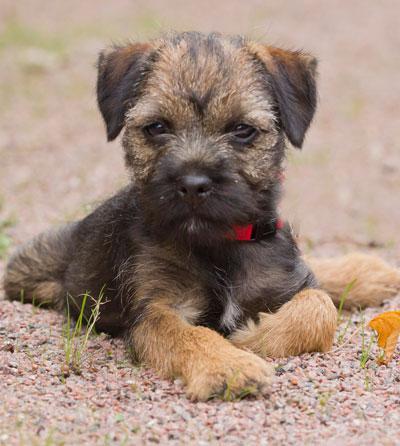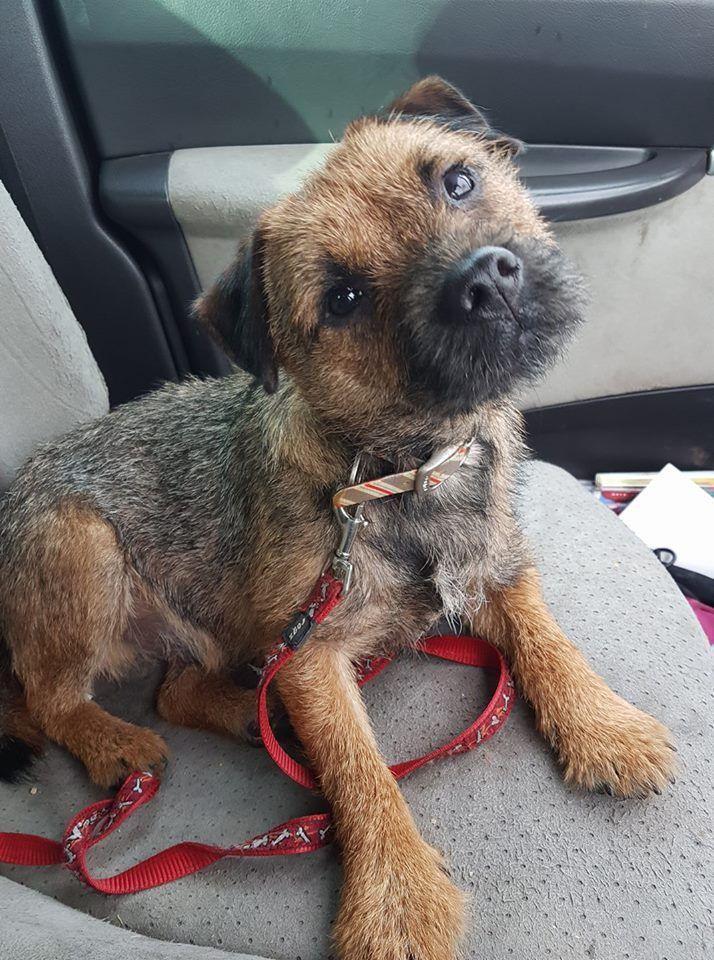The first image is the image on the left, the second image is the image on the right. Assess this claim about the two images: "The dog in the image on the left is wearing a red collar.". Correct or not? Answer yes or no. Yes. 